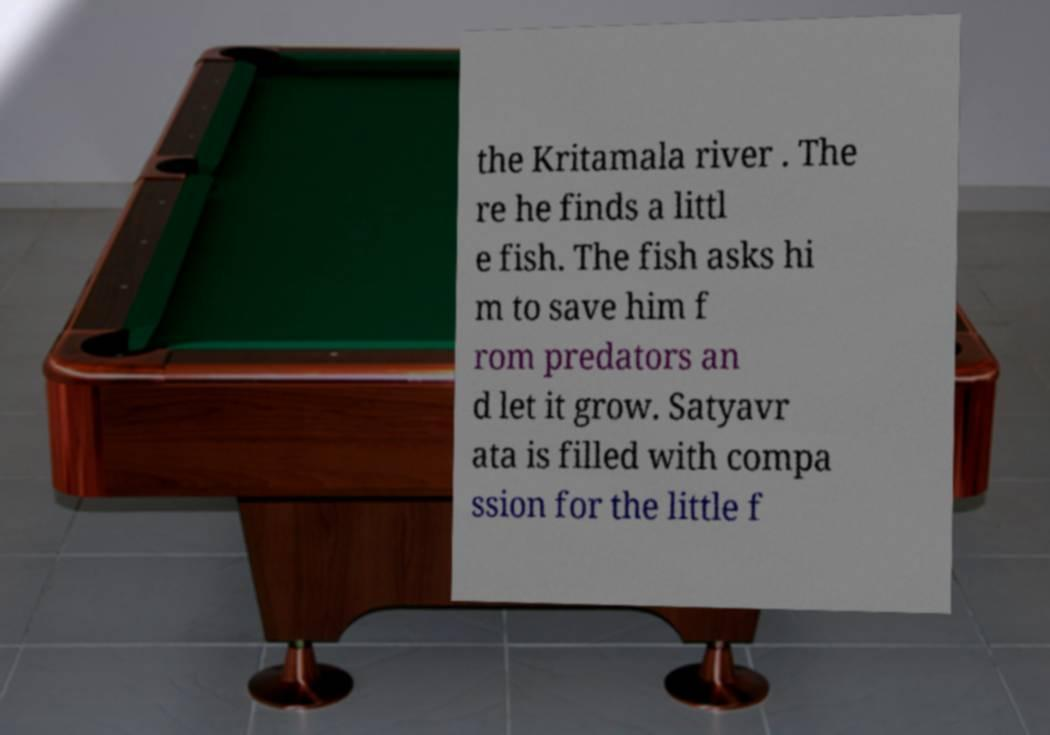I need the written content from this picture converted into text. Can you do that? the Kritamala river . The re he finds a littl e fish. The fish asks hi m to save him f rom predators an d let it grow. Satyavr ata is filled with compa ssion for the little f 